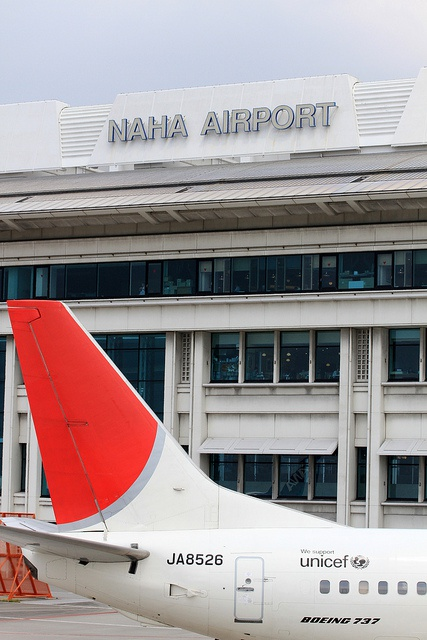Describe the objects in this image and their specific colors. I can see a airplane in lavender, white, red, darkgray, and gray tones in this image. 